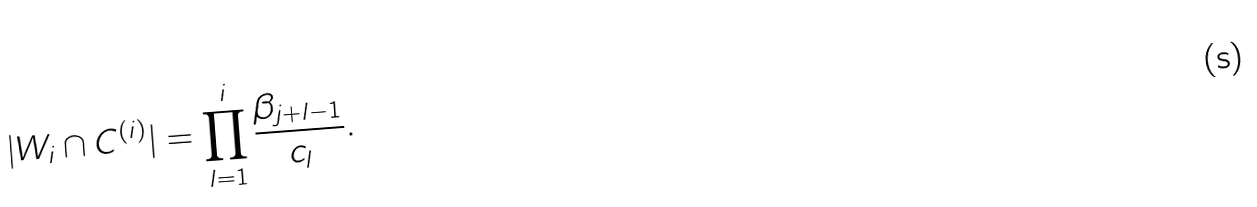Convert formula to latex. <formula><loc_0><loc_0><loc_500><loc_500>| W _ { i } \cap C ^ { ( i ) } | = \prod _ { l = 1 } ^ { i } \frac { \beta _ { j + l - 1 } } { c _ { l } } .</formula> 